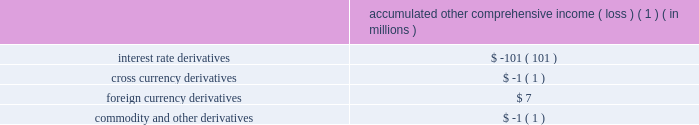The aes corporation notes to consolidated financial statements 2014 ( continued ) december 31 , 2011 , 2010 , and 2009 the table below sets forth the pre-tax accumulated other comprehensive income ( loss ) expected to be recognized as an increase ( decrease ) to income from continuing operations before income taxes over the next twelve months as of december 31 , 2011 for the following types of derivative instruments : accumulated other comprehensive income ( loss ) ( 1 ) ( in millions ) .
( 1 ) excludes a loss of $ 94 million expected to be recognized as part of the sale of cartagena , which closed on february 9 , 2012 , and is further discussed in note 23 2014acquisitions and dispositions .
The balance in accumulated other comprehensive loss related to derivative transactions will be reclassified into earnings as interest expense is recognized for interest rate hedges and cross currency swaps ( except for the amount reclassified to foreign currency transaction gains and losses to offset the remeasurement of the foreign currency-denominated debt being hedged by the cross currency swaps ) , as depreciation is recognized for interest rate hedges during construction , as foreign currency transaction gains and losses are recognized for hedges of foreign currency exposure , and as electricity sales and fuel purchases are recognized for hedges of forecasted electricity and fuel transactions .
These balances are included in the consolidated statements of cash flows as operating and/or investing activities based on the nature of the underlying transaction .
For the years ended december 31 , 2011 , 2010 and 2009 , pre-tax gains ( losses ) of $ 0 million , $ ( 1 ) million , and $ 0 million net of noncontrolling interests , respectively , were reclassified into earnings as a result of the discontinuance of a cash flow hedge because it was probable that the forecasted transaction would not occur by the end of the originally specified time period ( as documented at the inception of the hedging relationship ) or within an additional two-month time period thereafter. .
The loss on the sale of cartagena is what percent of the aoci impact of interest rate derivatives? 
Computations: (94 / 101)
Answer: 0.93069. 